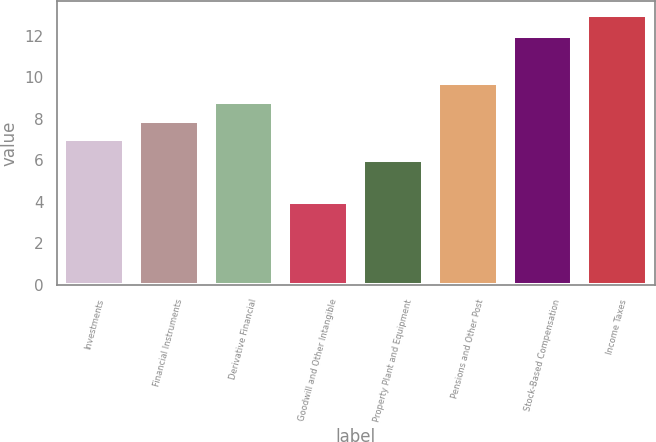Convert chart. <chart><loc_0><loc_0><loc_500><loc_500><bar_chart><fcel>Investments<fcel>Financial Instruments<fcel>Derivative Financial<fcel>Goodwill and Other Intangible<fcel>Property Plant and Equipment<fcel>Pensions and Other Post<fcel>Stock-Based Compensation<fcel>Income Taxes<nl><fcel>7<fcel>7.9<fcel>8.8<fcel>4<fcel>6<fcel>9.7<fcel>12<fcel>13<nl></chart> 